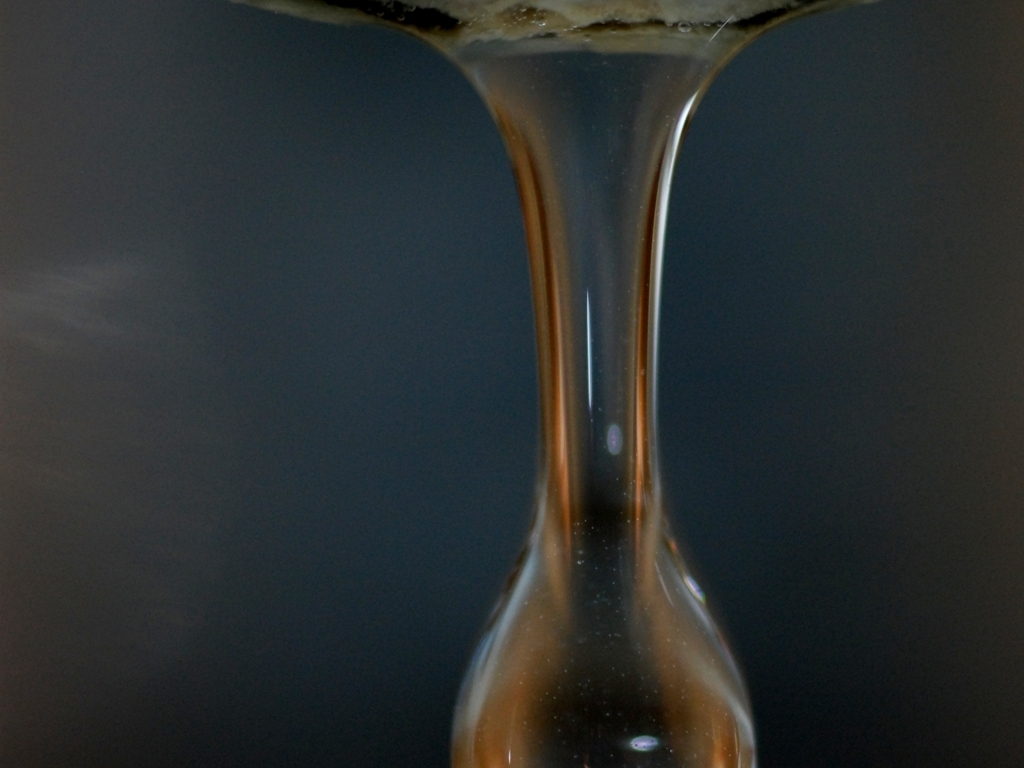Can you explain the artistic elements present in this photograph? This photograph displays a minimalist composition focusing on the droplet of liquid, which provides a sense of purity and simplicity. The use of a narrow depth of field emphasizes the droplet and blurs the background, creating an abstract quality. The contrasting colors and the play of light and shadow also contribute to the artistic value of the image. 